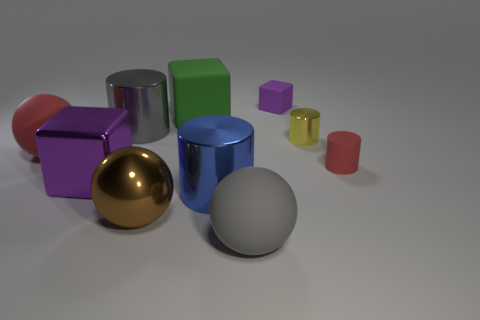There is a big object that is the same color as the tiny matte cube; what is it made of?
Provide a short and direct response. Metal. Are there fewer blue shiny things than purple objects?
Keep it short and to the point. Yes. The other shiny object that is the same shape as the big green object is what color?
Your answer should be very brief. Purple. Is there anything else that is the same shape as the large green thing?
Give a very brief answer. Yes. Are there more large rubber things than big gray shiny objects?
Offer a terse response. Yes. What number of other objects are the same material as the big blue object?
Make the answer very short. 4. The purple object that is behind the large cylinder that is behind the purple object that is to the left of the green matte thing is what shape?
Give a very brief answer. Cube. Are there fewer metallic things in front of the big gray metal cylinder than gray spheres right of the purple rubber object?
Offer a terse response. No. Is there a big cube of the same color as the metal ball?
Make the answer very short. No. Is the material of the tiny yellow cylinder the same as the block right of the big gray ball?
Your answer should be compact. No. 